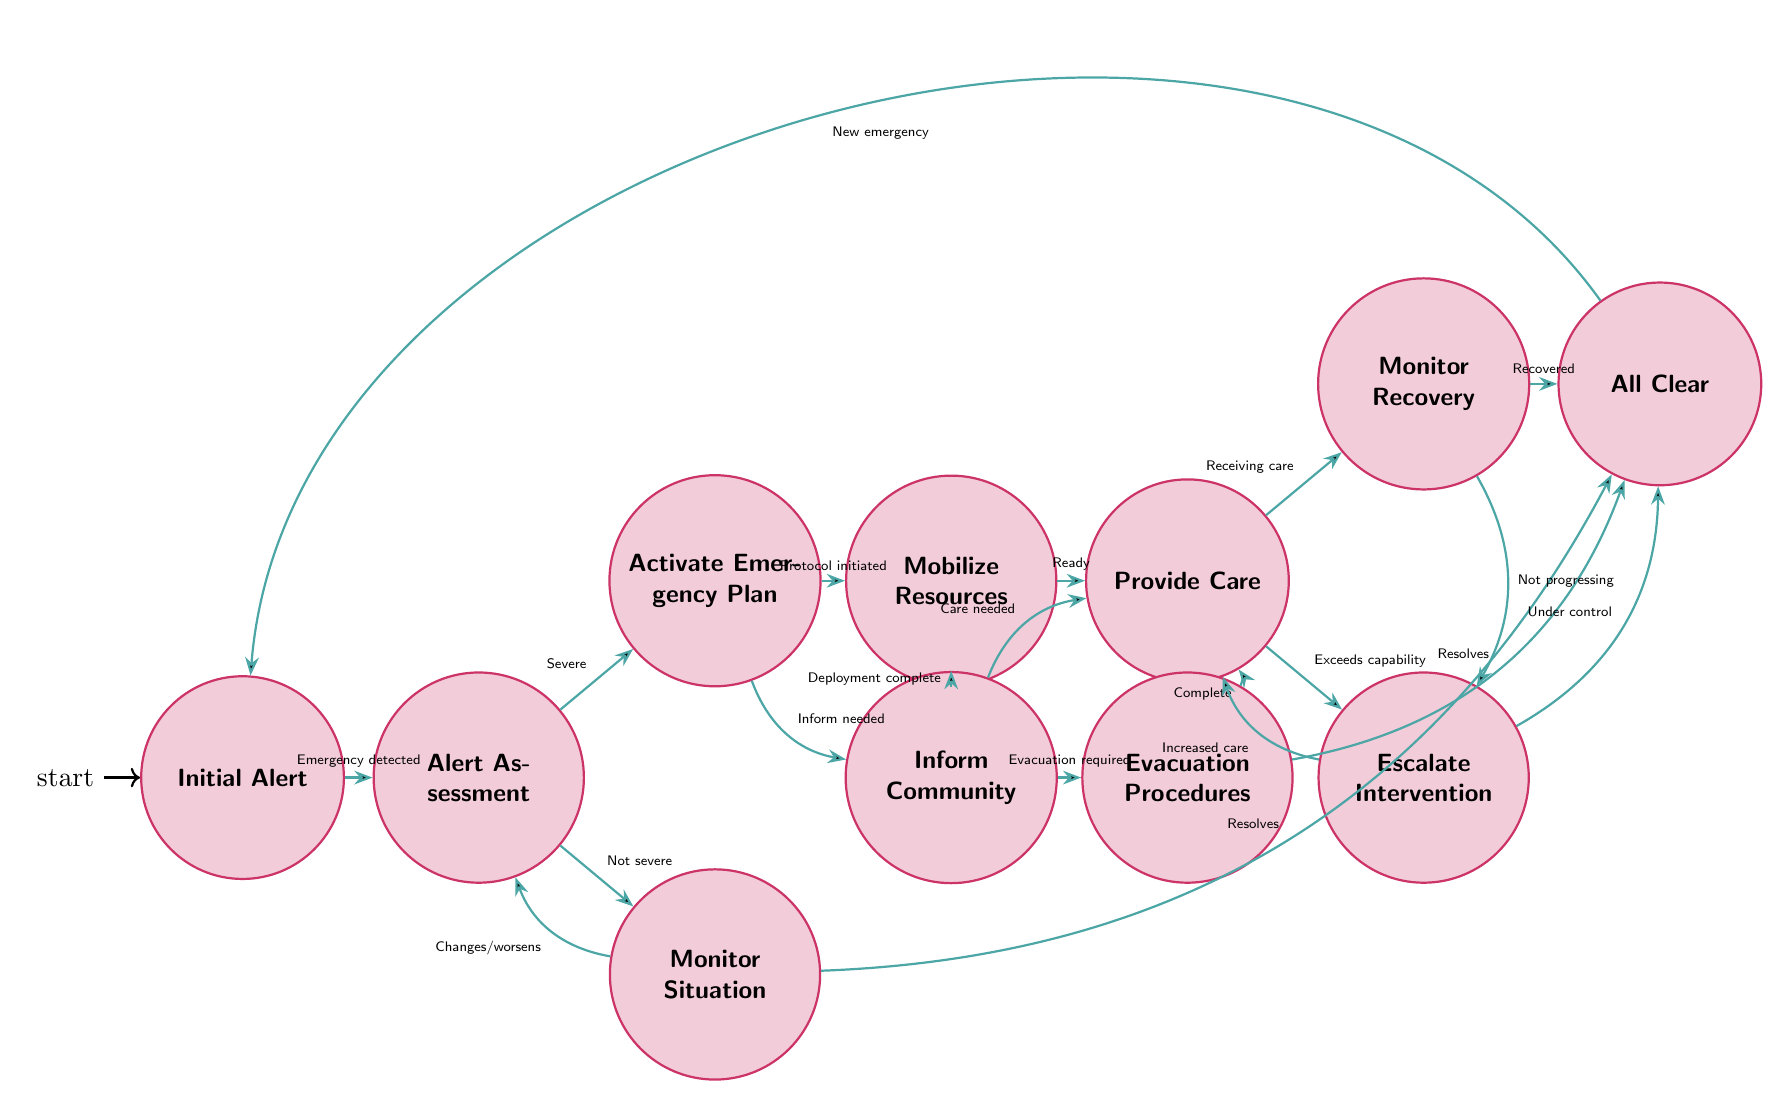What is the first state in the diagram? The diagram starts with the state "Initial Alert," which is the first state identified in the finite state machine.
Answer: Initial Alert How many transitions are there in total? By counting all the edges in the diagram, there are 20 transitions linking the states together.
Answer: 20 Which state follows "Alert Assessment" if the emergency is severe? If the emergency is assessed as severe, the next state transitioned to is "Activate Emergency Plan," as indicated by the transition that follows this condition.
Answer: Activate Emergency Plan What action occurs when the "Provide Care" state is reached? In the "Provide Care" state, two possible actions can occur: to monitor recovery or escalate intervention, based on the flow of transitions from this state.
Answer: Monitor Recovery or Escalate Intervention If the situation changes or worsens while in the "Monitor Situation" state, what is the next state? If the situation worsens, the finite state machine indicates a transition back to "Alert Assessment" for further evaluation of the emergency, as specified in the diagram.
Answer: Alert Assessment What happens once an emergency situation is declared "All Clear"? After the "All Clear" state is declared, the flow indicates readiness to address new emergencies, transitioning back to the "Initial Alert" state.
Answer: Initial Alert Which state indicates the need for evacuation? The state "Evacuation Procedures" indicates that evacuation is required, based on the transition from "Inform Community."
Answer: Evacuation Procedures What does "Escalate Intervention" allow medical responders to do? The "Escalate Intervention" state allows responders to increase the level of medical care needed when circumstances exceed initial capabilities, transitioning back to either "Provide Care" or "All Clear."
Answer: Increase care Which state do you reach if the emergency situation resolves without further action? If the emergency resolves without further action while in "Monitor Situation," the next state transitioned to is "All Clear," signifying the situation is under control.
Answer: All Clear What informs the transition to "Mobilize Resources"? The transition to "Mobilize Resources" occurs once the "Activate Emergency Plan" state has been executed and the emergency protocol has been initiated.
Answer: Activate Emergency Plan 